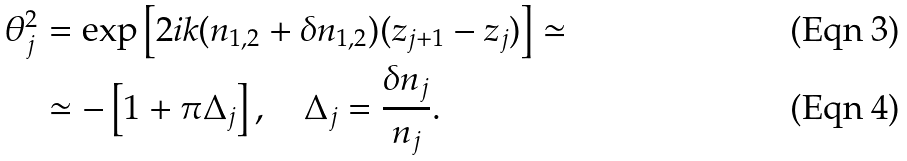Convert formula to latex. <formula><loc_0><loc_0><loc_500><loc_500>\theta _ { j } ^ { 2 } & = \exp \left [ 2 i k ( n _ { 1 , 2 } + \delta n _ { 1 , 2 } ) ( z _ { j + 1 } - z _ { j } ) \right ] \simeq \\ & \simeq - \left [ 1 + \pi \Delta _ { j } \right ] , \quad \Delta _ { j } = \frac { \delta n _ { j } } { n _ { j } } .</formula> 